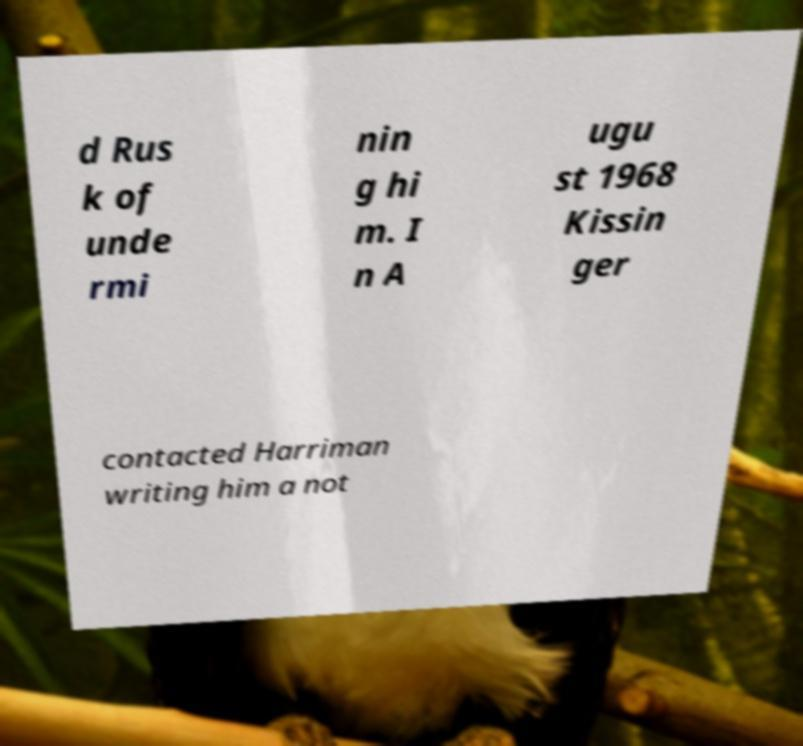Can you accurately transcribe the text from the provided image for me? d Rus k of unde rmi nin g hi m. I n A ugu st 1968 Kissin ger contacted Harriman writing him a not 